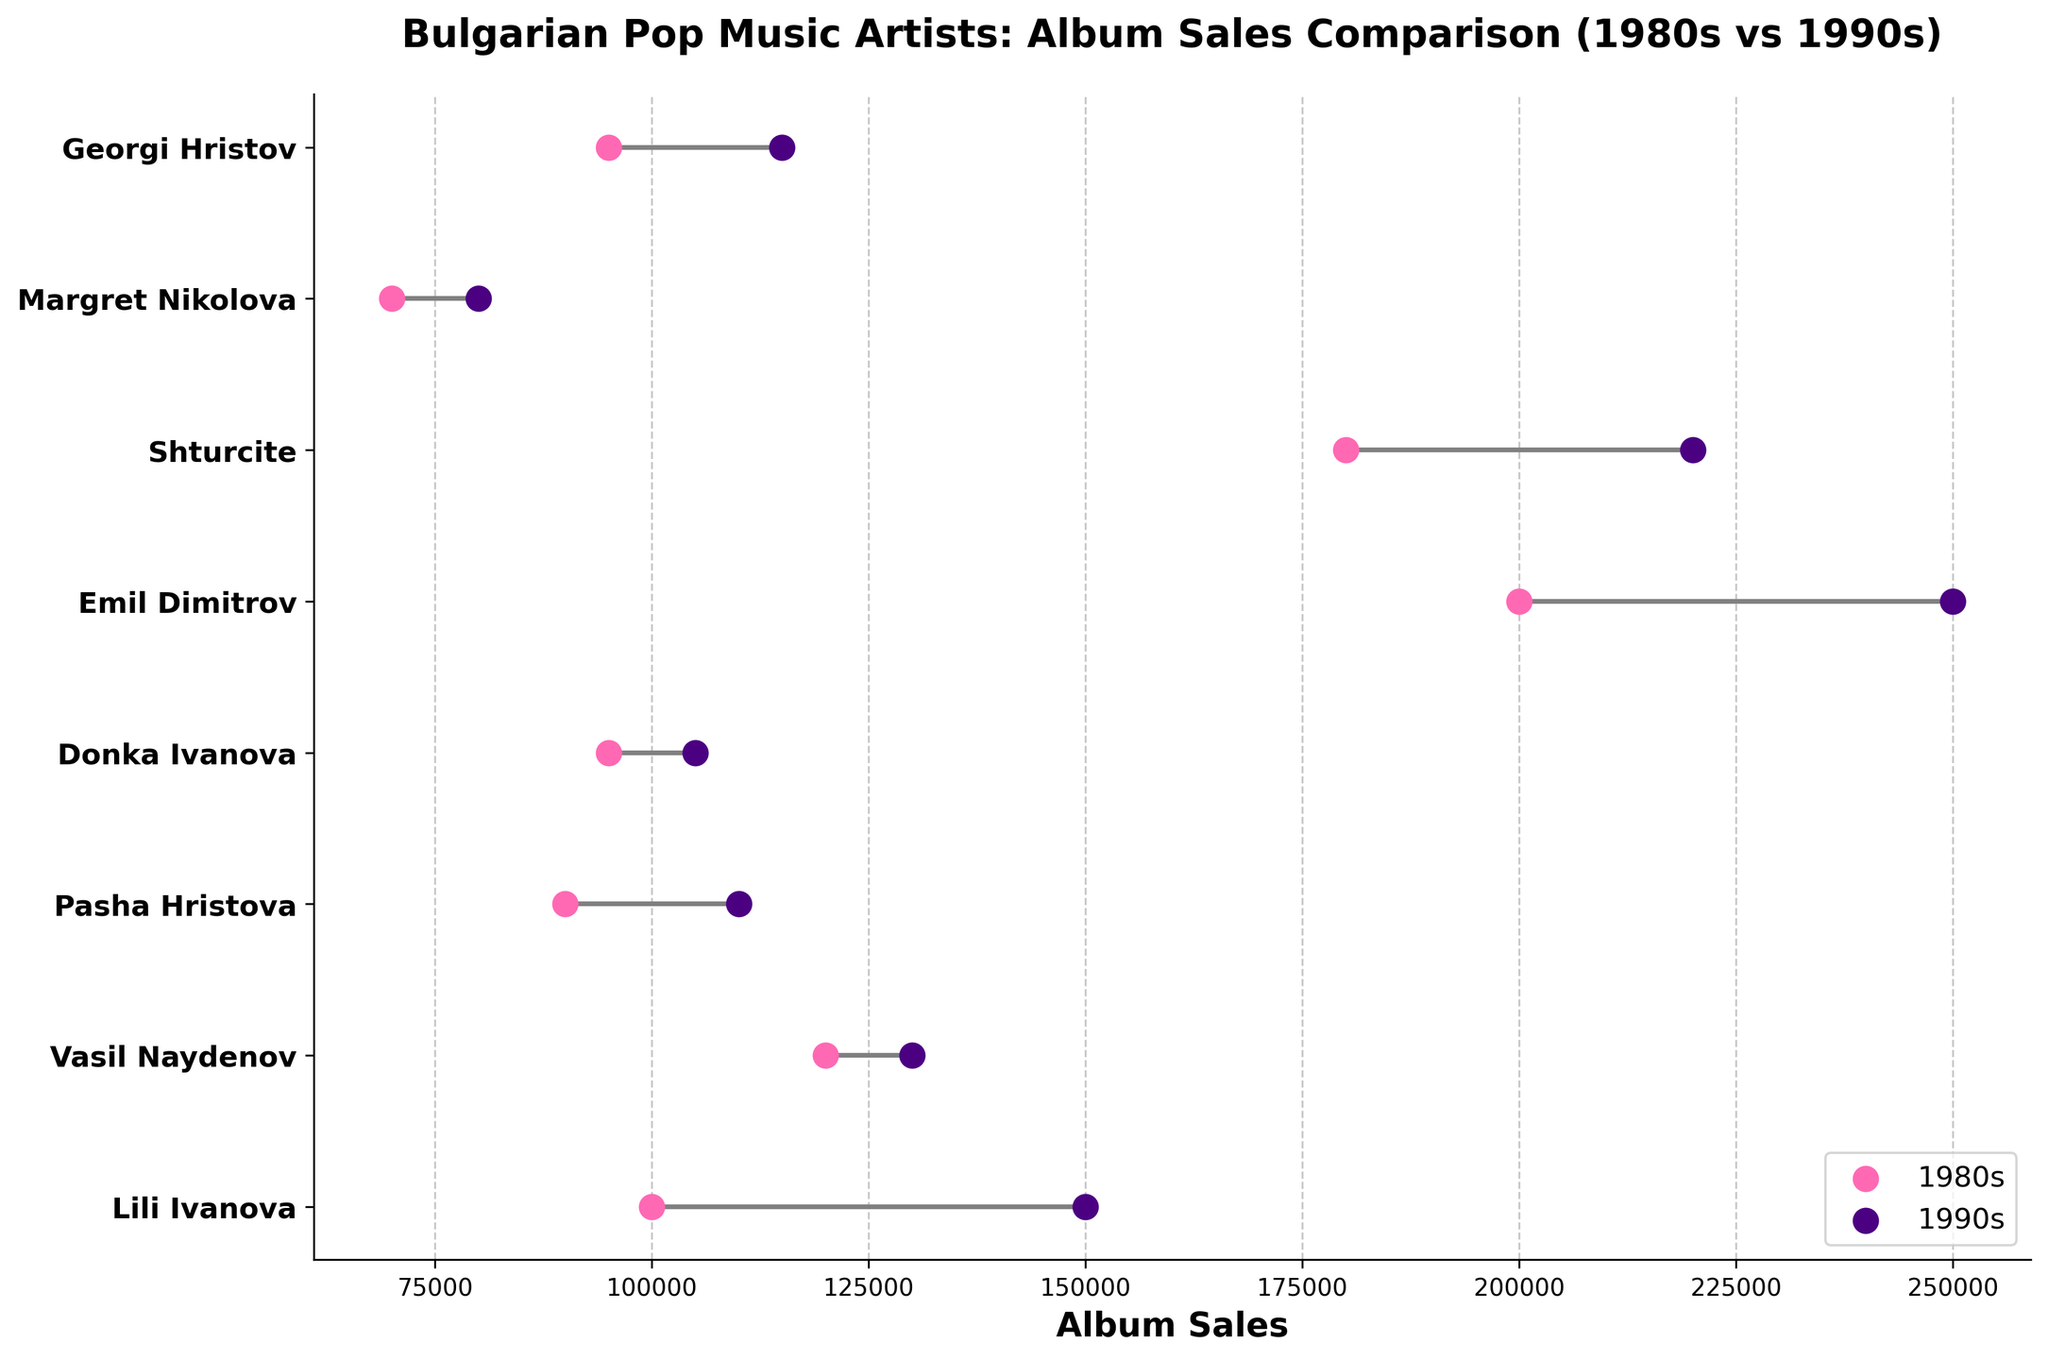What is the title of the figure? The title is written at the top of the figure and is intended to provide a clear summary of the content.
Answer: Bulgarian Pop Music Artists: Album Sales Comparison (1980s vs 1990s) What color represents album sales in the 1980s? The color corresponding to the 1980s sales is shown in the legend of the plot.
Answer: Pink Which artist sold the most albums in the 1990s? By examining the dots on the plot for the highest sales in the 1990s, the top dot corresponds to the artist.
Answer: Emil Dimitrov Which artist had the smallest increase in album sales from the 1980s to the 1990s? Calculate the difference in sales for each artist by subtracting 1980s sales from 1990s sales. The artist with the smallest positive difference or smallest decrease is the answer.
Answer: Donka Ivanova How many artists sold more than 100,000 albums in the 1980s? Check the 1980s dots for each artist and count those with sales figures exceeding 100,000.
Answer: 5 What is the average increase in album sales from the 1980s to the 1990s across all artists? Calculate the difference in sales for each artist, sum the differences, and divide by the number of artists: ((150000-100000)+(130000-120000)+(110000-90000)+(105000-95000)+(250000-200000)+(220000-180000)+(80000-70000)+(115000-95000))/8.
Answer: 22500 Which artist had the largest drop in album sales from the 1980s to the 1990s? Find the sales difference for each artist and identify the one with the largest negative difference.
Answer: None; all had an increase Compare the album sales of Shturcite in the 1980s vs the 1990s. Which was higher? Locate the dots for Shturcite and compare their positions along the x-axis.
Answer: 1990s What is the total album sales of Lili Ivanova for both decades combined? Add the sales numbers from both decades for Lili Ivanova (100000 + 150000).
Answer: 250000 Which two artists had the most similar album sales in the 1990s? Compare the sales figures of all artists for the 1990s and identify the two with the smallest difference.
Answer: Pasha Hristova and Georgi Hristov 